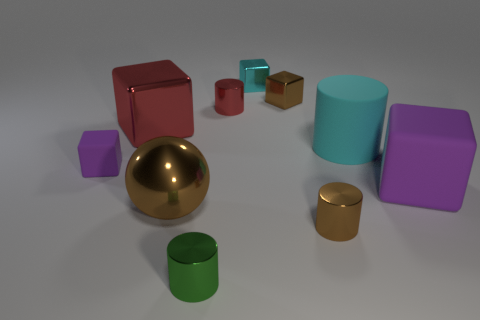Subtract all yellow spheres. How many purple blocks are left? 2 Subtract 1 cylinders. How many cylinders are left? 3 Subtract all red blocks. How many blocks are left? 4 Subtract all large cylinders. How many cylinders are left? 3 Subtract all gray cylinders. Subtract all red spheres. How many cylinders are left? 4 Subtract all cylinders. How many objects are left? 6 Add 7 red shiny things. How many red shiny things exist? 9 Subtract 1 brown spheres. How many objects are left? 9 Subtract all large brown metal things. Subtract all tiny green cylinders. How many objects are left? 8 Add 1 large purple cubes. How many large purple cubes are left? 2 